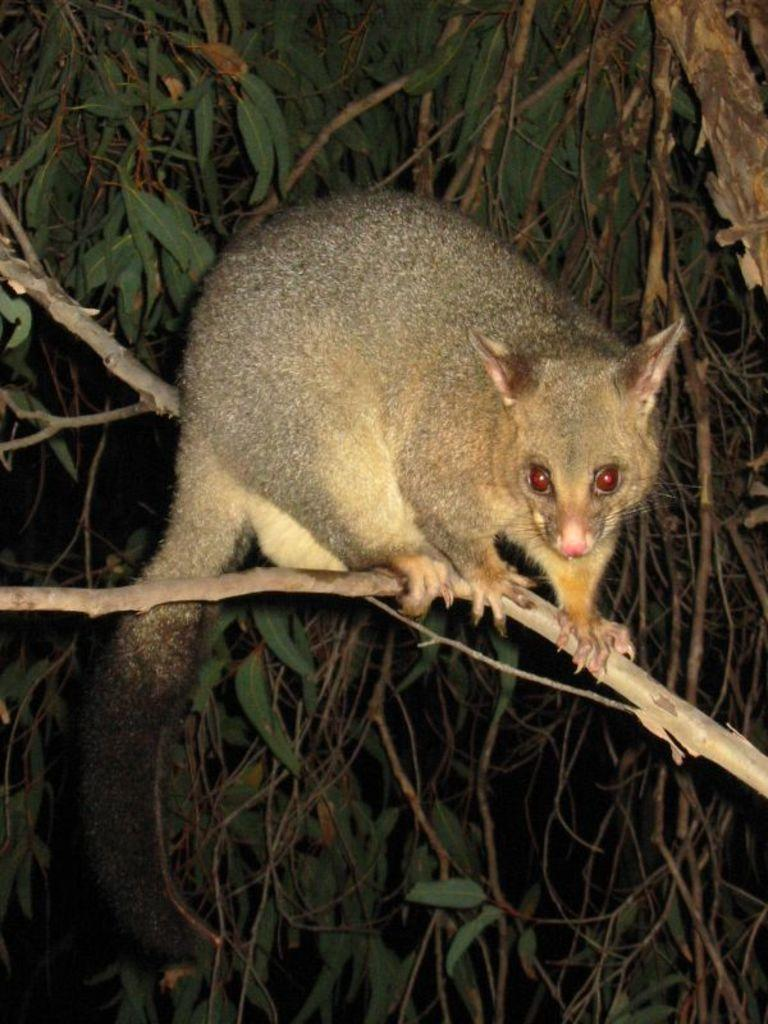What is on the tree branch in the image? There is an animal on a tree branch in the image. What can be seen in the background of the image? There are leaves visible in the background of the image. What letter can be seen on the tree branch in the image? There are no letters visible on the tree branch in the image. How many cats are present in the image? There are no cats present in the image; it features an animal on a tree branch. 